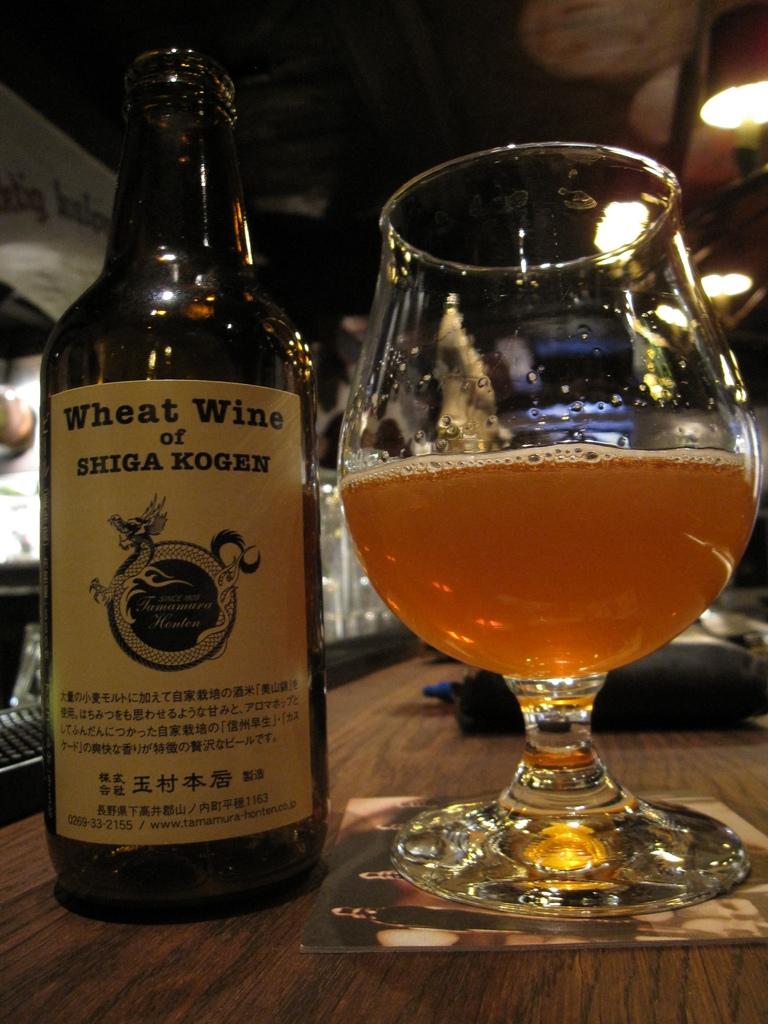What type of wine is this?
Your response must be concise. Wheat wine. 